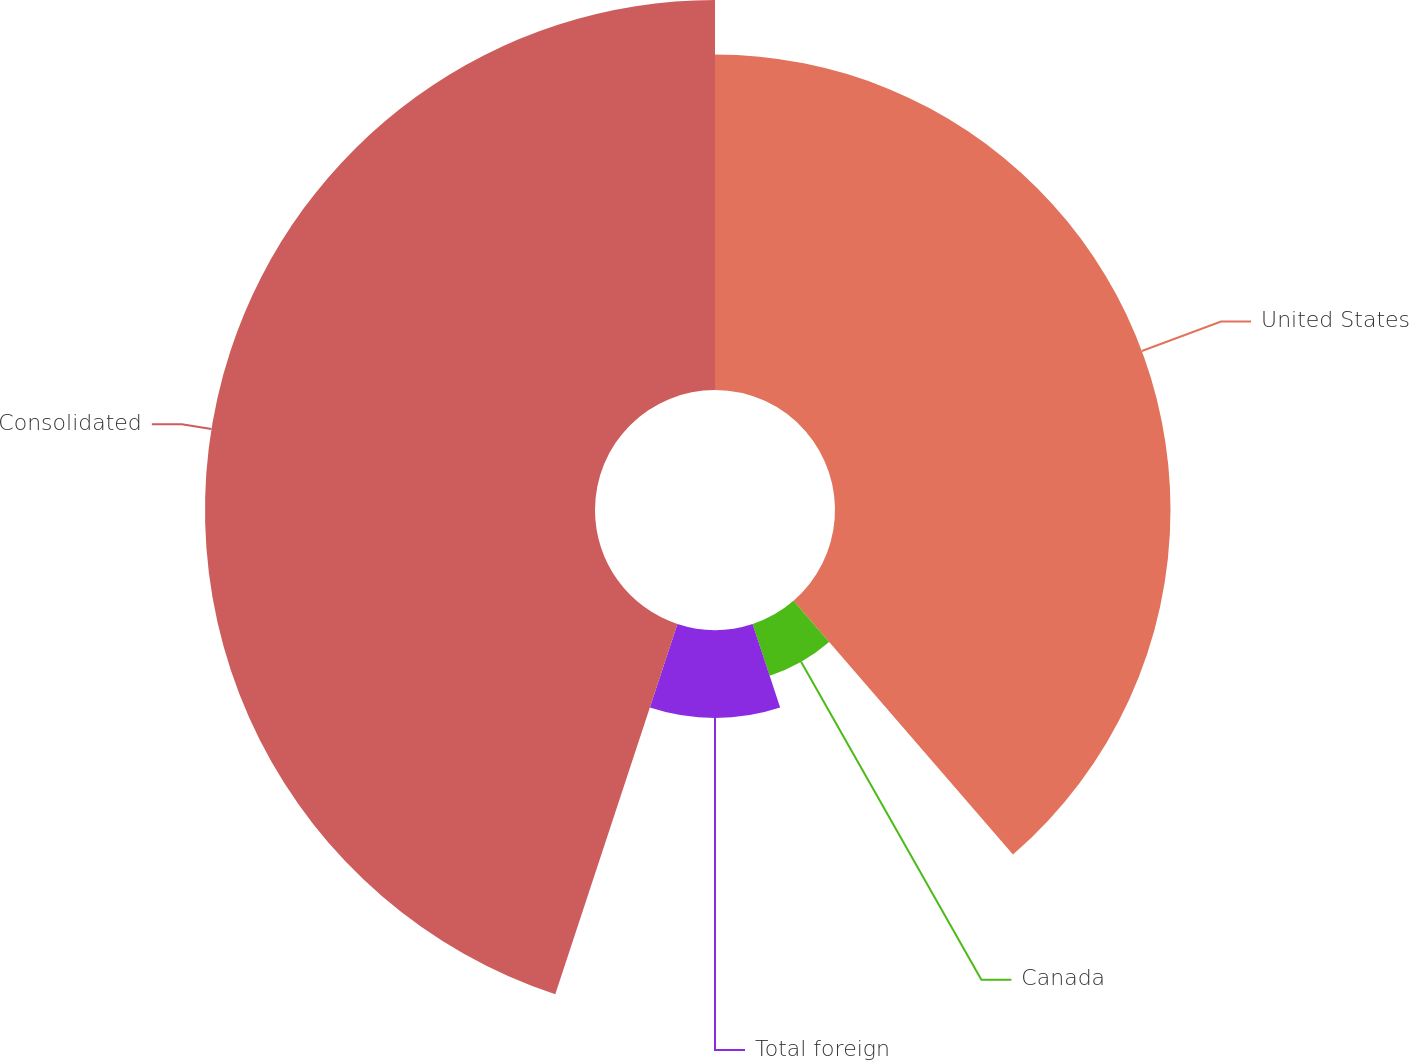Convert chart to OTSL. <chart><loc_0><loc_0><loc_500><loc_500><pie_chart><fcel>United States<fcel>Canada<fcel>Total foreign<fcel>Consolidated<nl><fcel>38.65%<fcel>6.28%<fcel>10.14%<fcel>44.93%<nl></chart> 